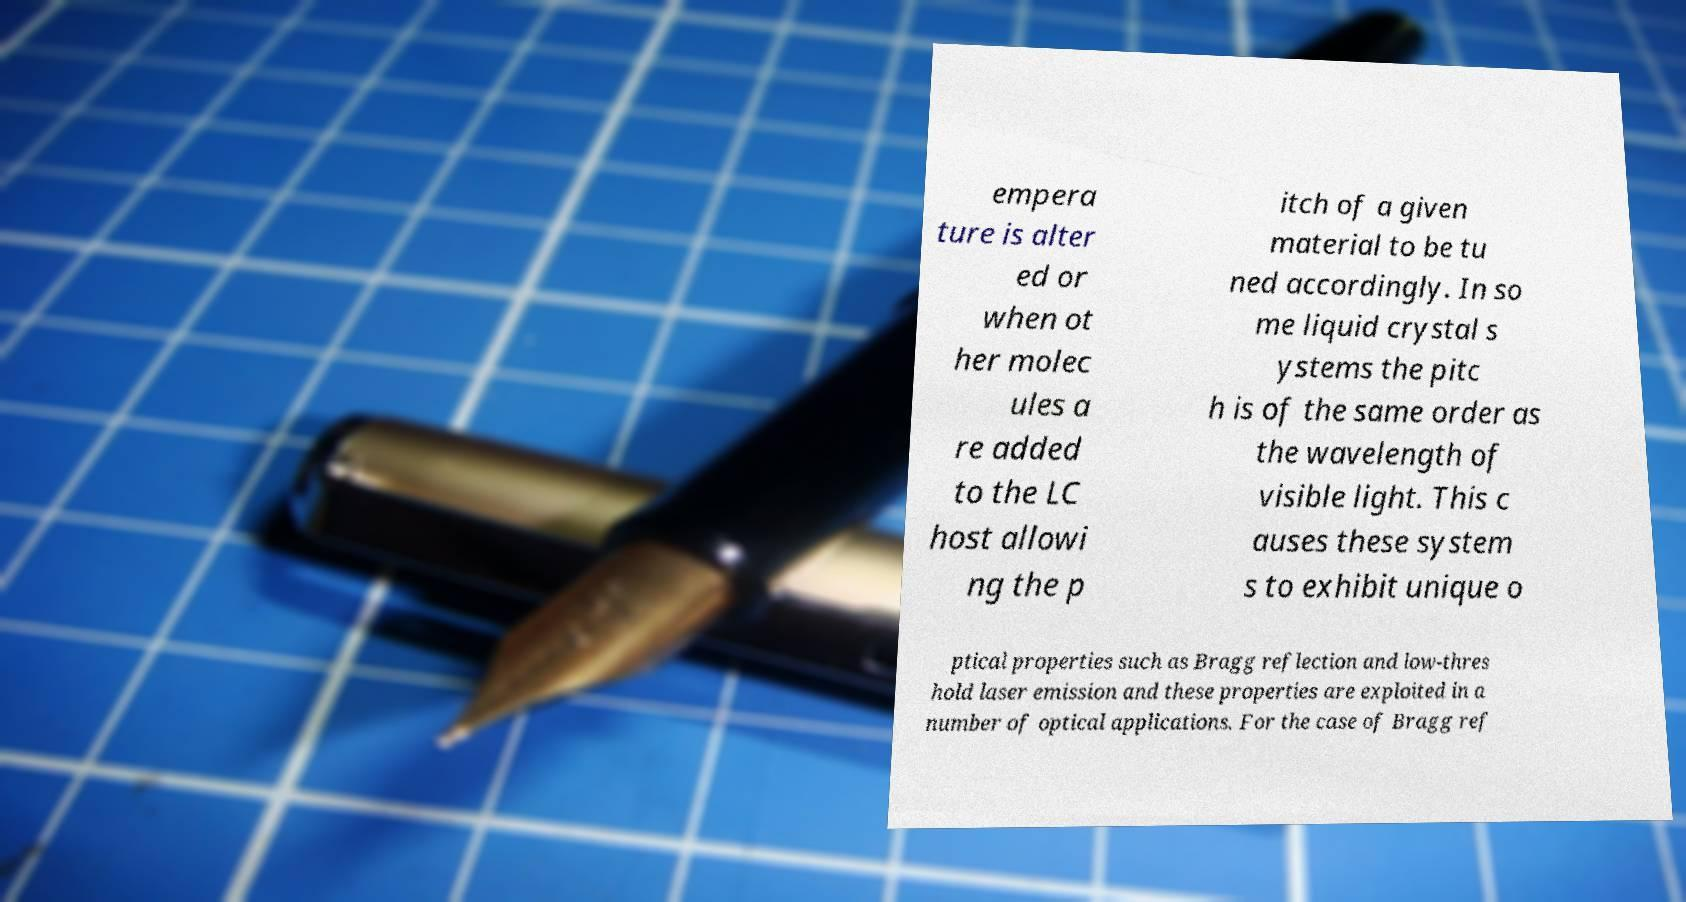Please read and relay the text visible in this image. What does it say? empera ture is alter ed or when ot her molec ules a re added to the LC host allowi ng the p itch of a given material to be tu ned accordingly. In so me liquid crystal s ystems the pitc h is of the same order as the wavelength of visible light. This c auses these system s to exhibit unique o ptical properties such as Bragg reflection and low-thres hold laser emission and these properties are exploited in a number of optical applications. For the case of Bragg ref 